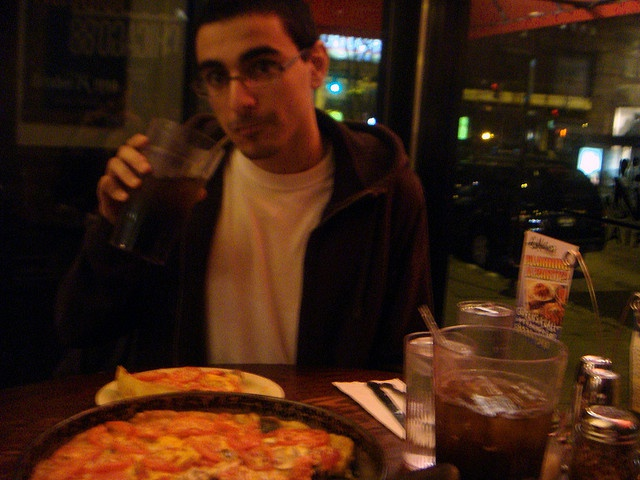Describe the objects in this image and their specific colors. I can see people in black, maroon, and brown tones, pizza in black, red, brown, and maroon tones, cup in black, maroon, and brown tones, car in black, maroon, olive, and navy tones, and dining table in black, maroon, brown, and orange tones in this image. 